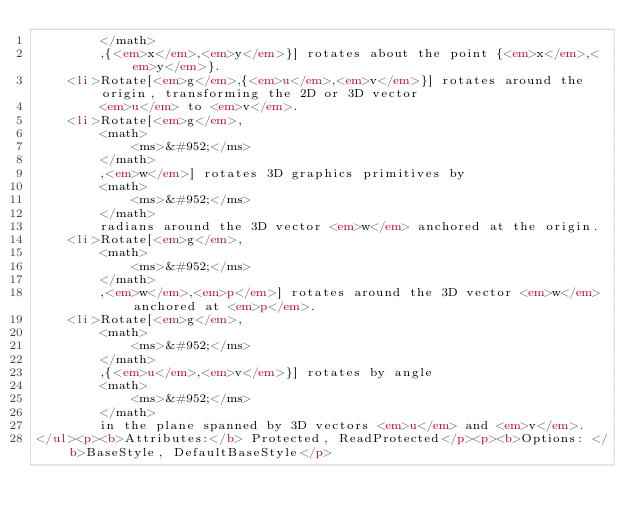<code> <loc_0><loc_0><loc_500><loc_500><_HTML_>        </math>
        ,{<em>x</em>,<em>y</em>}] rotates about the point {<em>x</em>,<em>y</em>}.
    <li>Rotate[<em>g</em>,{<em>u</em>,<em>v</em>}] rotates around the origin, transforming the 2D or 3D vector
        <em>u</em> to <em>v</em>.
    <li>Rotate[<em>g</em>,
        <math>
            <ms>&#952;</ms>
        </math>
        ,<em>w</em>] rotates 3D graphics primitives by
        <math>
            <ms>&#952;</ms>
        </math>
        radians around the 3D vector <em>w</em> anchored at the origin.
    <li>Rotate[<em>g</em>,
        <math>
            <ms>&#952;</ms>
        </math>
        ,<em>w</em>,<em>p</em>] rotates around the 3D vector <em>w</em> anchored at <em>p</em>.
    <li>Rotate[<em>g</em>,
        <math>
            <ms>&#952;</ms>
        </math>
        ,{<em>u</em>,<em>v</em>}] rotates by angle
        <math>
            <ms>&#952;</ms>
        </math>
        in the plane spanned by 3D vectors <em>u</em> and <em>v</em>.
</ul><p><b>Attributes:</b> Protected, ReadProtected</p><p><b>Options: </b>BaseStyle, DefaultBaseStyle</p></code> 